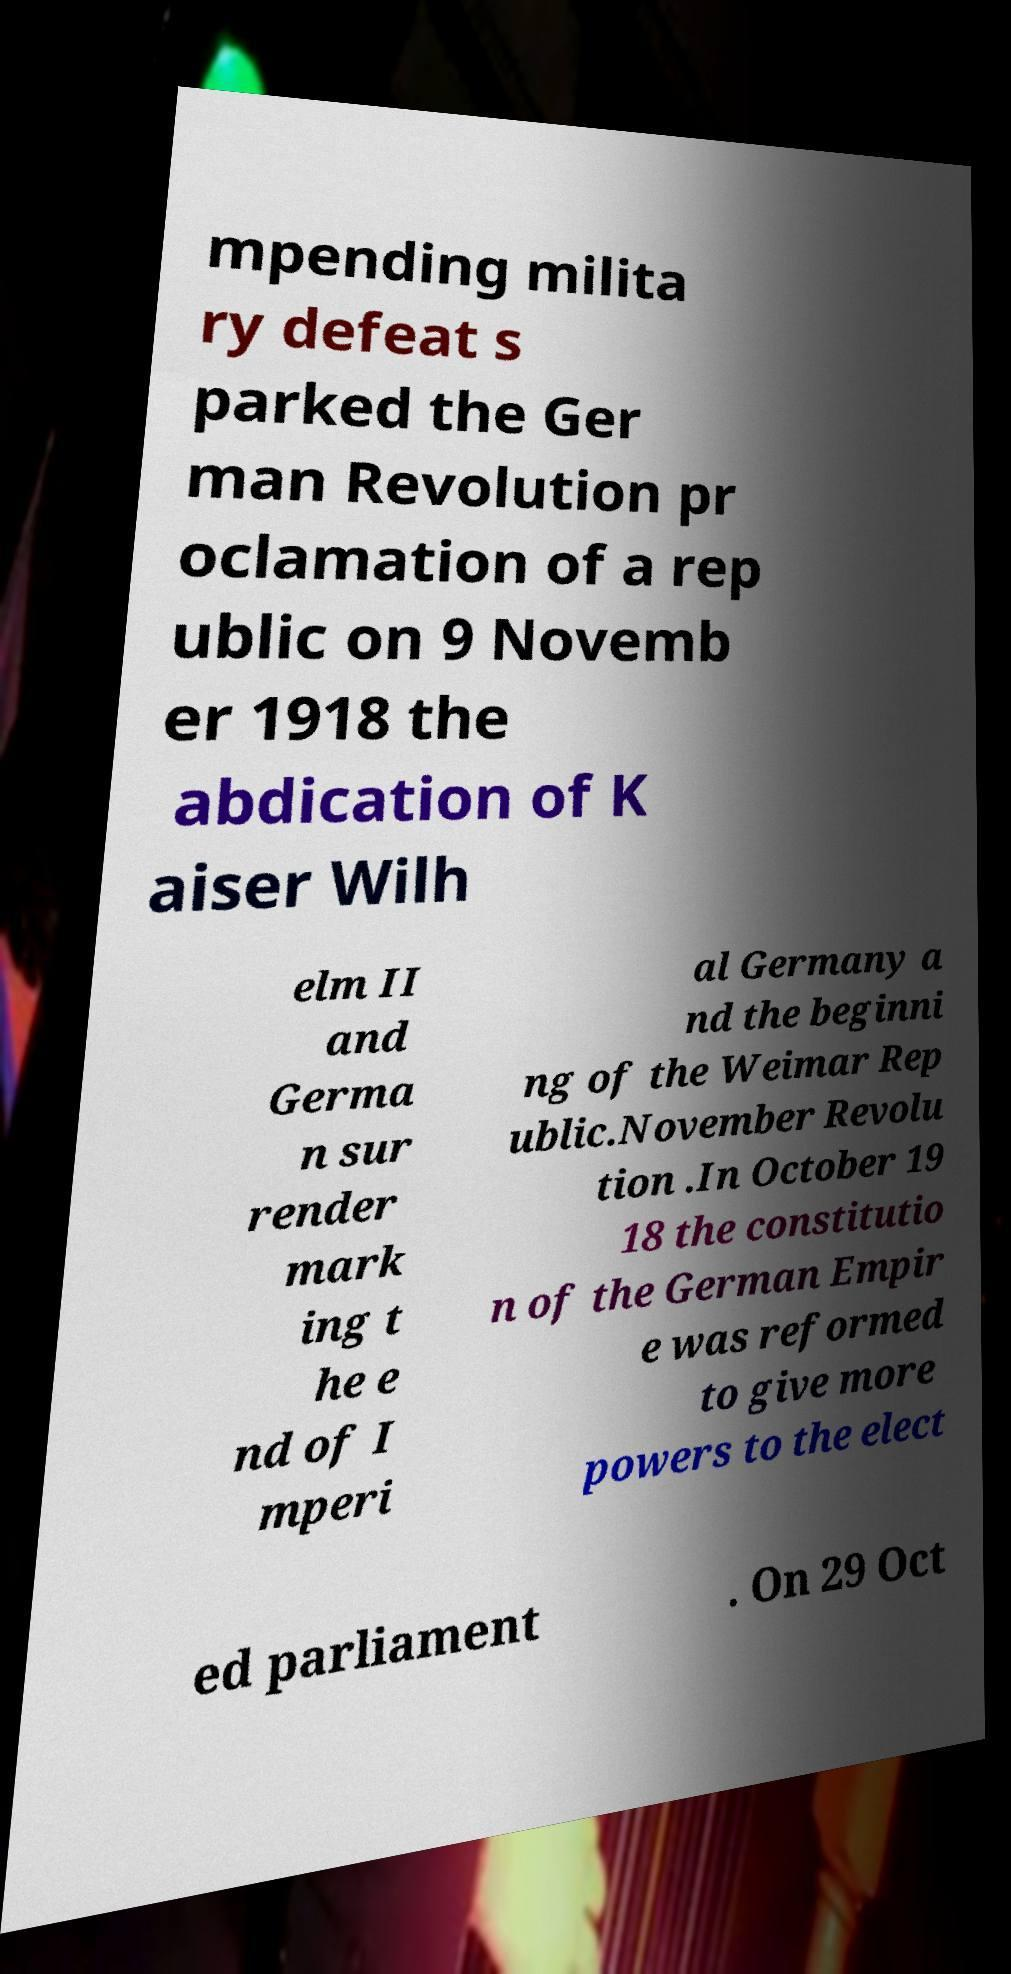What messages or text are displayed in this image? I need them in a readable, typed format. mpending milita ry defeat s parked the Ger man Revolution pr oclamation of a rep ublic on 9 Novemb er 1918 the abdication of K aiser Wilh elm II and Germa n sur render mark ing t he e nd of I mperi al Germany a nd the beginni ng of the Weimar Rep ublic.November Revolu tion .In October 19 18 the constitutio n of the German Empir e was reformed to give more powers to the elect ed parliament . On 29 Oct 